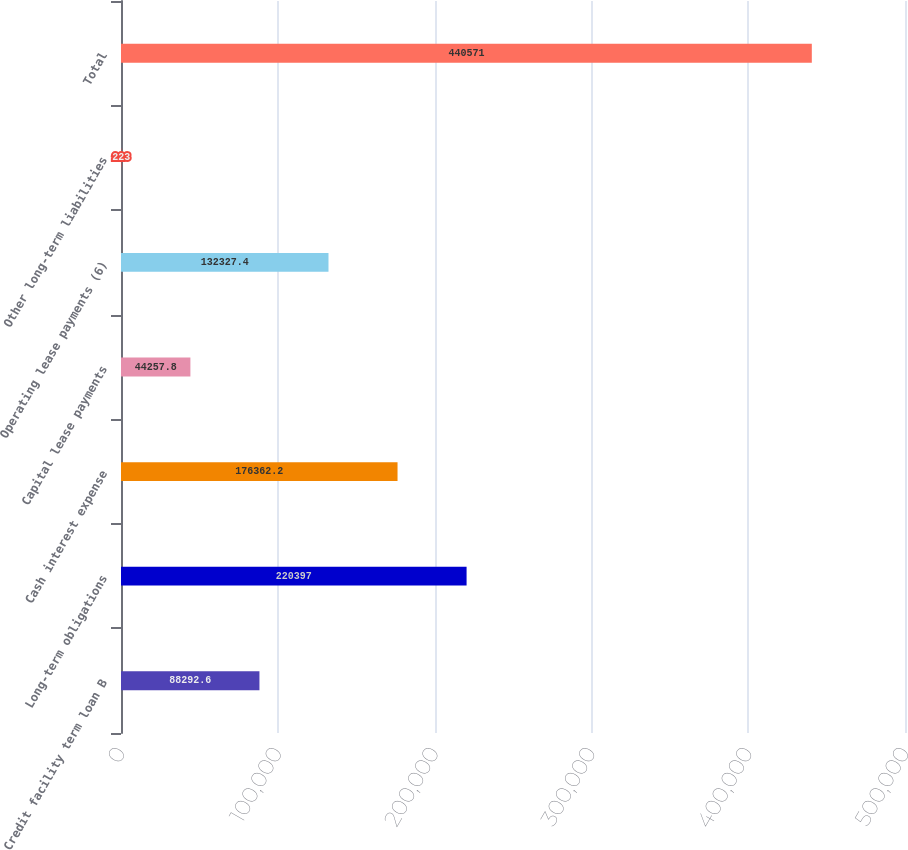Convert chart. <chart><loc_0><loc_0><loc_500><loc_500><bar_chart><fcel>Credit facility term loan B<fcel>Long-term obligations<fcel>Cash interest expense<fcel>Capital lease payments<fcel>Operating lease payments (6)<fcel>Other long-term liabilities<fcel>Total<nl><fcel>88292.6<fcel>220397<fcel>176362<fcel>44257.8<fcel>132327<fcel>223<fcel>440571<nl></chart> 